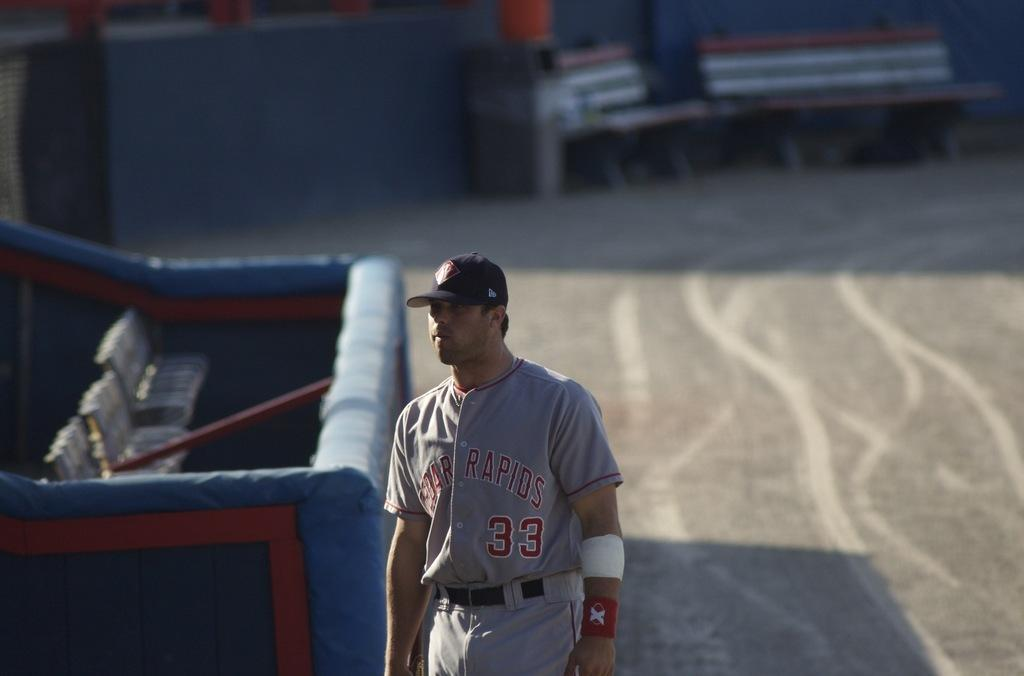<image>
Relay a brief, clear account of the picture shown. A baseball player from Cedar Rapids is on the field. 